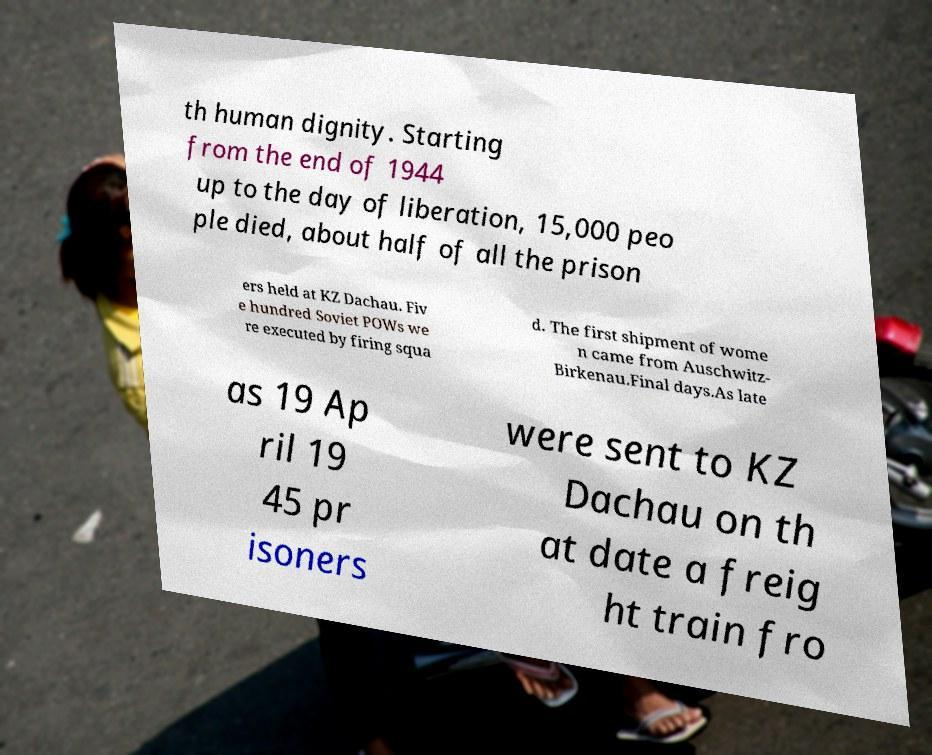What messages or text are displayed in this image? I need them in a readable, typed format. th human dignity. Starting from the end of 1944 up to the day of liberation, 15,000 peo ple died, about half of all the prison ers held at KZ Dachau. Fiv e hundred Soviet POWs we re executed by firing squa d. The first shipment of wome n came from Auschwitz- Birkenau.Final days.As late as 19 Ap ril 19 45 pr isoners were sent to KZ Dachau on th at date a freig ht train fro 